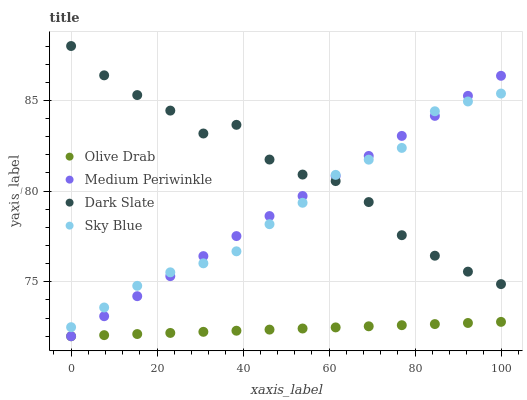Does Olive Drab have the minimum area under the curve?
Answer yes or no. Yes. Does Dark Slate have the maximum area under the curve?
Answer yes or no. Yes. Does Medium Periwinkle have the minimum area under the curve?
Answer yes or no. No. Does Medium Periwinkle have the maximum area under the curve?
Answer yes or no. No. Is Olive Drab the smoothest?
Answer yes or no. Yes. Is Dark Slate the roughest?
Answer yes or no. Yes. Is Medium Periwinkle the smoothest?
Answer yes or no. No. Is Medium Periwinkle the roughest?
Answer yes or no. No. Does Medium Periwinkle have the lowest value?
Answer yes or no. Yes. Does Sky Blue have the lowest value?
Answer yes or no. No. Does Dark Slate have the highest value?
Answer yes or no. Yes. Does Medium Periwinkle have the highest value?
Answer yes or no. No. Is Olive Drab less than Sky Blue?
Answer yes or no. Yes. Is Sky Blue greater than Olive Drab?
Answer yes or no. Yes. Does Olive Drab intersect Medium Periwinkle?
Answer yes or no. Yes. Is Olive Drab less than Medium Periwinkle?
Answer yes or no. No. Is Olive Drab greater than Medium Periwinkle?
Answer yes or no. No. Does Olive Drab intersect Sky Blue?
Answer yes or no. No. 